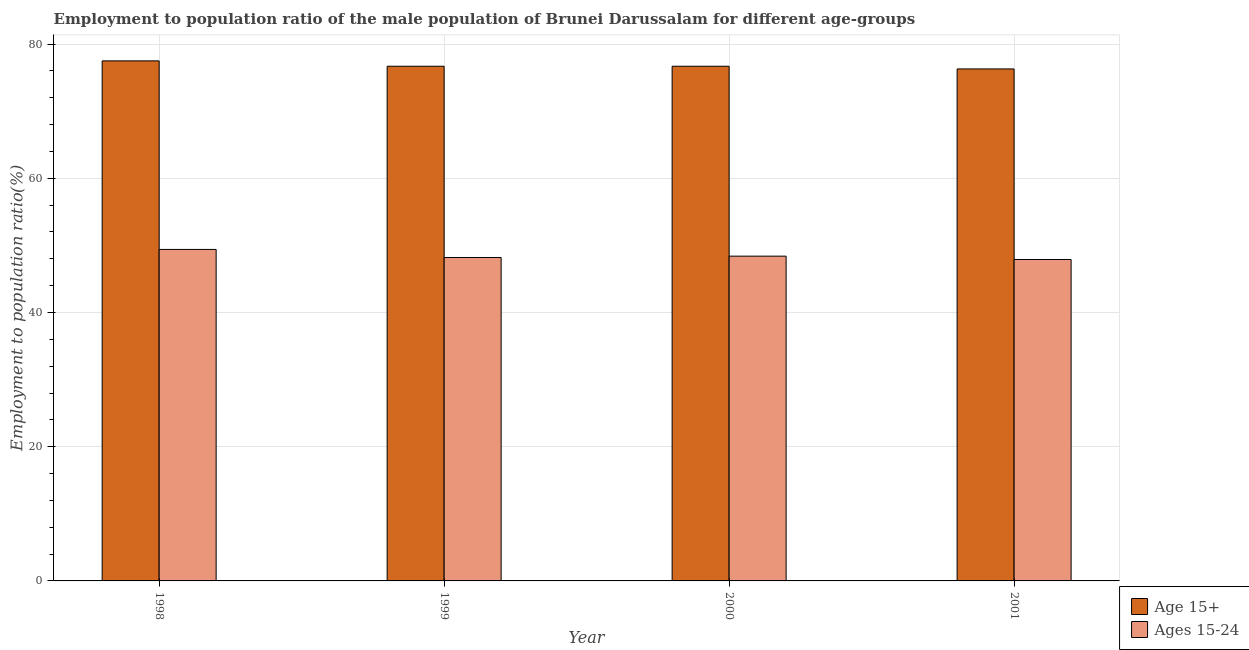How many different coloured bars are there?
Your response must be concise. 2. How many groups of bars are there?
Offer a terse response. 4. How many bars are there on the 1st tick from the left?
Your answer should be very brief. 2. How many bars are there on the 4th tick from the right?
Offer a very short reply. 2. In how many cases, is the number of bars for a given year not equal to the number of legend labels?
Your answer should be very brief. 0. What is the employment to population ratio(age 15-24) in 1998?
Make the answer very short. 49.4. Across all years, what is the maximum employment to population ratio(age 15-24)?
Provide a succinct answer. 49.4. Across all years, what is the minimum employment to population ratio(age 15-24)?
Ensure brevity in your answer.  47.9. What is the total employment to population ratio(age 15+) in the graph?
Your answer should be compact. 307.2. What is the difference between the employment to population ratio(age 15+) in 1999 and that in 2001?
Offer a very short reply. 0.4. What is the difference between the employment to population ratio(age 15+) in 2001 and the employment to population ratio(age 15-24) in 1998?
Ensure brevity in your answer.  -1.2. What is the average employment to population ratio(age 15+) per year?
Offer a terse response. 76.8. In the year 1999, what is the difference between the employment to population ratio(age 15-24) and employment to population ratio(age 15+)?
Your answer should be very brief. 0. In how many years, is the employment to population ratio(age 15-24) greater than 68 %?
Give a very brief answer. 0. What is the ratio of the employment to population ratio(age 15+) in 1998 to that in 1999?
Give a very brief answer. 1.01. Is the employment to population ratio(age 15+) in 2000 less than that in 2001?
Offer a terse response. No. What is the difference between the highest and the second highest employment to population ratio(age 15-24)?
Provide a short and direct response. 1. What is the difference between the highest and the lowest employment to population ratio(age 15-24)?
Keep it short and to the point. 1.5. In how many years, is the employment to population ratio(age 15+) greater than the average employment to population ratio(age 15+) taken over all years?
Provide a succinct answer. 1. Is the sum of the employment to population ratio(age 15+) in 1999 and 2000 greater than the maximum employment to population ratio(age 15-24) across all years?
Offer a terse response. Yes. What does the 2nd bar from the left in 2001 represents?
Provide a short and direct response. Ages 15-24. What does the 1st bar from the right in 2000 represents?
Give a very brief answer. Ages 15-24. Are all the bars in the graph horizontal?
Provide a short and direct response. No. Are the values on the major ticks of Y-axis written in scientific E-notation?
Give a very brief answer. No. Does the graph contain grids?
Offer a terse response. Yes. Where does the legend appear in the graph?
Provide a succinct answer. Bottom right. How many legend labels are there?
Ensure brevity in your answer.  2. What is the title of the graph?
Provide a short and direct response. Employment to population ratio of the male population of Brunei Darussalam for different age-groups. What is the Employment to population ratio(%) in Age 15+ in 1998?
Your answer should be very brief. 77.5. What is the Employment to population ratio(%) in Ages 15-24 in 1998?
Provide a succinct answer. 49.4. What is the Employment to population ratio(%) of Age 15+ in 1999?
Provide a succinct answer. 76.7. What is the Employment to population ratio(%) in Ages 15-24 in 1999?
Your answer should be compact. 48.2. What is the Employment to population ratio(%) in Age 15+ in 2000?
Offer a very short reply. 76.7. What is the Employment to population ratio(%) of Ages 15-24 in 2000?
Give a very brief answer. 48.4. What is the Employment to population ratio(%) in Age 15+ in 2001?
Your answer should be very brief. 76.3. What is the Employment to population ratio(%) in Ages 15-24 in 2001?
Make the answer very short. 47.9. Across all years, what is the maximum Employment to population ratio(%) in Age 15+?
Provide a succinct answer. 77.5. Across all years, what is the maximum Employment to population ratio(%) of Ages 15-24?
Make the answer very short. 49.4. Across all years, what is the minimum Employment to population ratio(%) of Age 15+?
Give a very brief answer. 76.3. Across all years, what is the minimum Employment to population ratio(%) in Ages 15-24?
Your response must be concise. 47.9. What is the total Employment to population ratio(%) in Age 15+ in the graph?
Ensure brevity in your answer.  307.2. What is the total Employment to population ratio(%) of Ages 15-24 in the graph?
Offer a terse response. 193.9. What is the difference between the Employment to population ratio(%) of Ages 15-24 in 1998 and that in 1999?
Your answer should be compact. 1.2. What is the difference between the Employment to population ratio(%) in Age 15+ in 1999 and that in 2001?
Provide a succinct answer. 0.4. What is the difference between the Employment to population ratio(%) of Ages 15-24 in 2000 and that in 2001?
Keep it short and to the point. 0.5. What is the difference between the Employment to population ratio(%) of Age 15+ in 1998 and the Employment to population ratio(%) of Ages 15-24 in 1999?
Provide a short and direct response. 29.3. What is the difference between the Employment to population ratio(%) in Age 15+ in 1998 and the Employment to population ratio(%) in Ages 15-24 in 2000?
Provide a succinct answer. 29.1. What is the difference between the Employment to population ratio(%) in Age 15+ in 1998 and the Employment to population ratio(%) in Ages 15-24 in 2001?
Keep it short and to the point. 29.6. What is the difference between the Employment to population ratio(%) of Age 15+ in 1999 and the Employment to population ratio(%) of Ages 15-24 in 2000?
Ensure brevity in your answer.  28.3. What is the difference between the Employment to population ratio(%) in Age 15+ in 1999 and the Employment to population ratio(%) in Ages 15-24 in 2001?
Provide a short and direct response. 28.8. What is the difference between the Employment to population ratio(%) of Age 15+ in 2000 and the Employment to population ratio(%) of Ages 15-24 in 2001?
Offer a very short reply. 28.8. What is the average Employment to population ratio(%) of Age 15+ per year?
Your response must be concise. 76.8. What is the average Employment to population ratio(%) in Ages 15-24 per year?
Provide a succinct answer. 48.48. In the year 1998, what is the difference between the Employment to population ratio(%) in Age 15+ and Employment to population ratio(%) in Ages 15-24?
Your answer should be very brief. 28.1. In the year 1999, what is the difference between the Employment to population ratio(%) of Age 15+ and Employment to population ratio(%) of Ages 15-24?
Your response must be concise. 28.5. In the year 2000, what is the difference between the Employment to population ratio(%) of Age 15+ and Employment to population ratio(%) of Ages 15-24?
Offer a very short reply. 28.3. In the year 2001, what is the difference between the Employment to population ratio(%) in Age 15+ and Employment to population ratio(%) in Ages 15-24?
Keep it short and to the point. 28.4. What is the ratio of the Employment to population ratio(%) in Age 15+ in 1998 to that in 1999?
Your response must be concise. 1.01. What is the ratio of the Employment to population ratio(%) in Ages 15-24 in 1998 to that in 1999?
Make the answer very short. 1.02. What is the ratio of the Employment to population ratio(%) in Age 15+ in 1998 to that in 2000?
Make the answer very short. 1.01. What is the ratio of the Employment to population ratio(%) of Ages 15-24 in 1998 to that in 2000?
Make the answer very short. 1.02. What is the ratio of the Employment to population ratio(%) in Age 15+ in 1998 to that in 2001?
Offer a terse response. 1.02. What is the ratio of the Employment to population ratio(%) in Ages 15-24 in 1998 to that in 2001?
Offer a terse response. 1.03. What is the ratio of the Employment to population ratio(%) of Age 15+ in 1999 to that in 2001?
Provide a short and direct response. 1.01. What is the ratio of the Employment to population ratio(%) in Ages 15-24 in 1999 to that in 2001?
Keep it short and to the point. 1.01. What is the ratio of the Employment to population ratio(%) of Ages 15-24 in 2000 to that in 2001?
Ensure brevity in your answer.  1.01. What is the difference between the highest and the second highest Employment to population ratio(%) of Age 15+?
Your answer should be compact. 0.8. What is the difference between the highest and the lowest Employment to population ratio(%) in Ages 15-24?
Your answer should be compact. 1.5. 